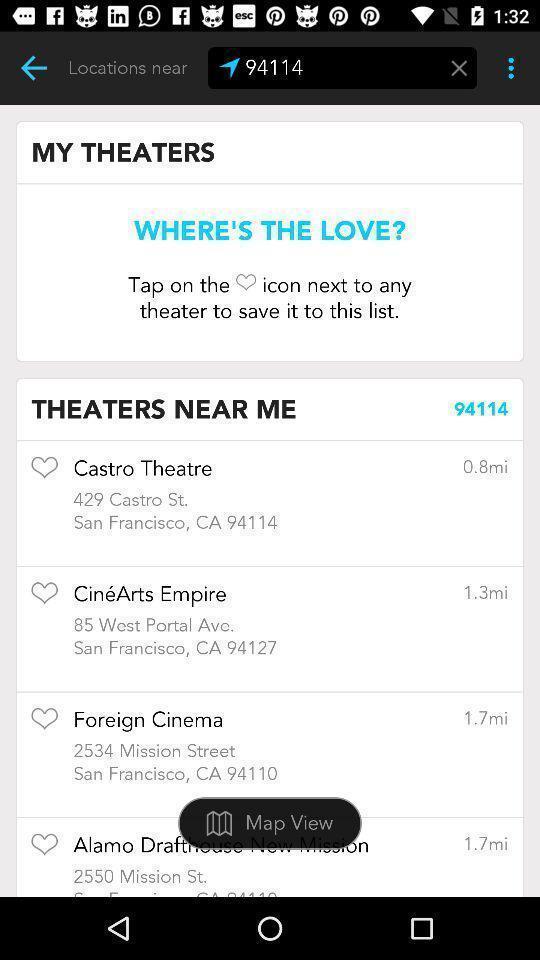What can you discern from this picture? Search results page displayed of a navigation app. 